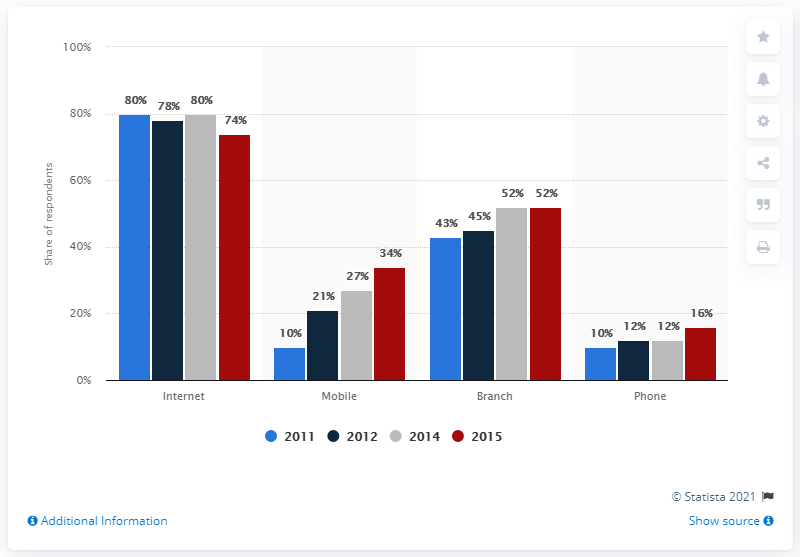Specify some key components in this picture. In 2011, the channel use rate was 10. Branch banking fluctuated between certain percentages, with a range of 10%. 